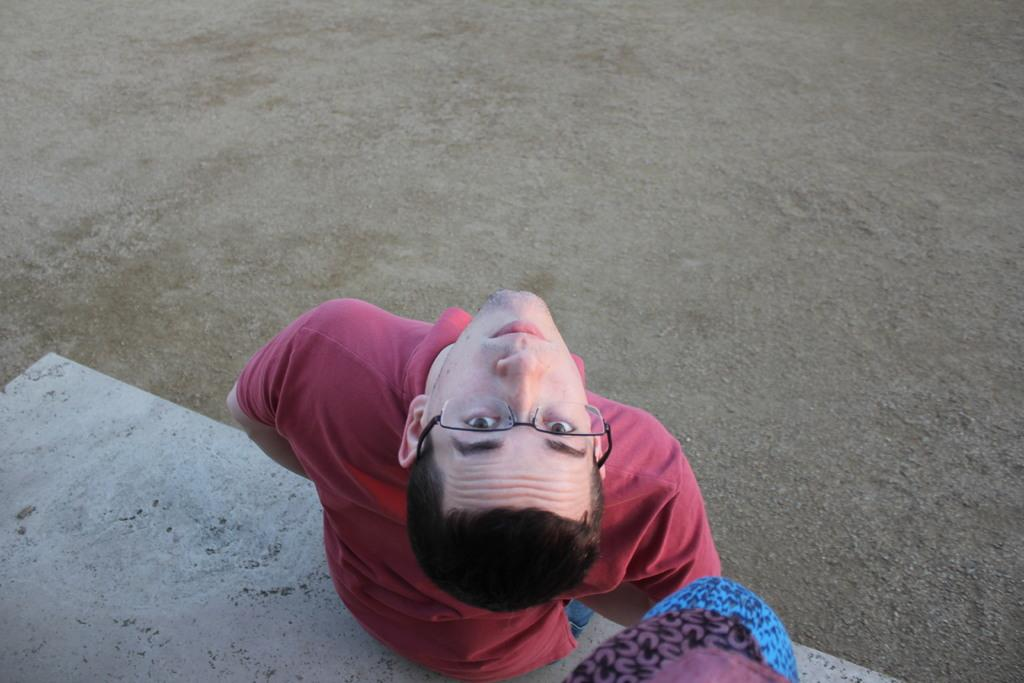What is the man in the image doing? The man is sitting in the image. Where is the man located in the image? The man is at the bottom of the image. What objects are beside the man? There are bags beside the man. What type of surface is at the bottom of the image? There is sand at the bottom of the image. What type of car can be seen driving through the sand in the image? There is no car present in the image; it only features a man sitting and bags beside him on a sandy surface. 